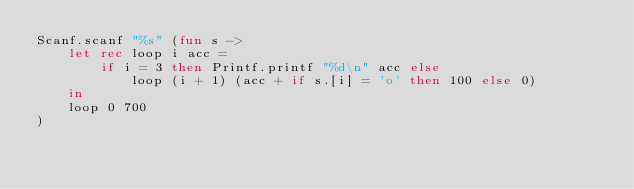Convert code to text. <code><loc_0><loc_0><loc_500><loc_500><_OCaml_>Scanf.scanf "%s" (fun s ->
    let rec loop i acc =
        if i = 3 then Printf.printf "%d\n" acc else
            loop (i + 1) (acc + if s.[i] = 'o' then 100 else 0)
    in
    loop 0 700
)</code> 